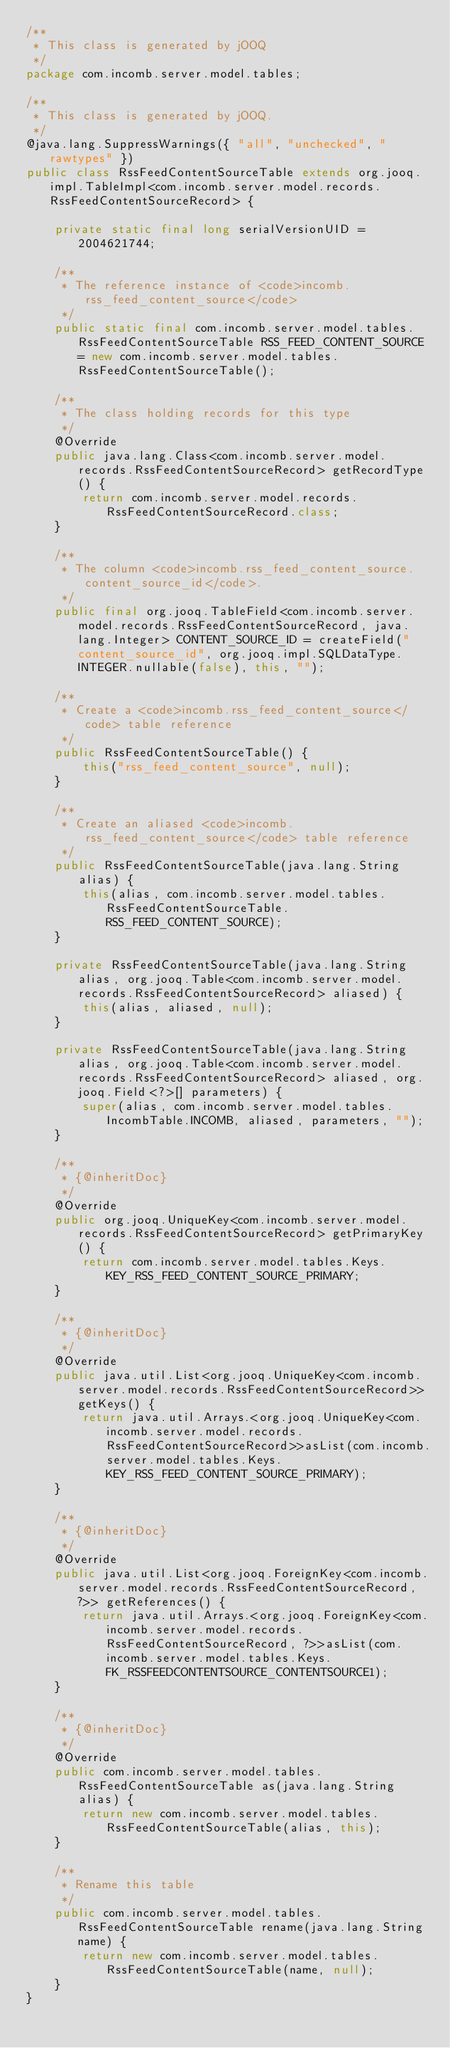<code> <loc_0><loc_0><loc_500><loc_500><_Java_>/**
 * This class is generated by jOOQ
 */
package com.incomb.server.model.tables;

/**
 * This class is generated by jOOQ.
 */
@java.lang.SuppressWarnings({ "all", "unchecked", "rawtypes" })
public class RssFeedContentSourceTable extends org.jooq.impl.TableImpl<com.incomb.server.model.records.RssFeedContentSourceRecord> {

	private static final long serialVersionUID = 2004621744;

	/**
	 * The reference instance of <code>incomb.rss_feed_content_source</code>
	 */
	public static final com.incomb.server.model.tables.RssFeedContentSourceTable RSS_FEED_CONTENT_SOURCE = new com.incomb.server.model.tables.RssFeedContentSourceTable();

	/**
	 * The class holding records for this type
	 */
	@Override
	public java.lang.Class<com.incomb.server.model.records.RssFeedContentSourceRecord> getRecordType() {
		return com.incomb.server.model.records.RssFeedContentSourceRecord.class;
	}

	/**
	 * The column <code>incomb.rss_feed_content_source.content_source_id</code>.
	 */
	public final org.jooq.TableField<com.incomb.server.model.records.RssFeedContentSourceRecord, java.lang.Integer> CONTENT_SOURCE_ID = createField("content_source_id", org.jooq.impl.SQLDataType.INTEGER.nullable(false), this, "");

	/**
	 * Create a <code>incomb.rss_feed_content_source</code> table reference
	 */
	public RssFeedContentSourceTable() {
		this("rss_feed_content_source", null);
	}

	/**
	 * Create an aliased <code>incomb.rss_feed_content_source</code> table reference
	 */
	public RssFeedContentSourceTable(java.lang.String alias) {
		this(alias, com.incomb.server.model.tables.RssFeedContentSourceTable.RSS_FEED_CONTENT_SOURCE);
	}

	private RssFeedContentSourceTable(java.lang.String alias, org.jooq.Table<com.incomb.server.model.records.RssFeedContentSourceRecord> aliased) {
		this(alias, aliased, null);
	}

	private RssFeedContentSourceTable(java.lang.String alias, org.jooq.Table<com.incomb.server.model.records.RssFeedContentSourceRecord> aliased, org.jooq.Field<?>[] parameters) {
		super(alias, com.incomb.server.model.tables.IncombTable.INCOMB, aliased, parameters, "");
	}

	/**
	 * {@inheritDoc}
	 */
	@Override
	public org.jooq.UniqueKey<com.incomb.server.model.records.RssFeedContentSourceRecord> getPrimaryKey() {
		return com.incomb.server.model.tables.Keys.KEY_RSS_FEED_CONTENT_SOURCE_PRIMARY;
	}

	/**
	 * {@inheritDoc}
	 */
	@Override
	public java.util.List<org.jooq.UniqueKey<com.incomb.server.model.records.RssFeedContentSourceRecord>> getKeys() {
		return java.util.Arrays.<org.jooq.UniqueKey<com.incomb.server.model.records.RssFeedContentSourceRecord>>asList(com.incomb.server.model.tables.Keys.KEY_RSS_FEED_CONTENT_SOURCE_PRIMARY);
	}

	/**
	 * {@inheritDoc}
	 */
	@Override
	public java.util.List<org.jooq.ForeignKey<com.incomb.server.model.records.RssFeedContentSourceRecord, ?>> getReferences() {
		return java.util.Arrays.<org.jooq.ForeignKey<com.incomb.server.model.records.RssFeedContentSourceRecord, ?>>asList(com.incomb.server.model.tables.Keys.FK_RSSFEEDCONTENTSOURCE_CONTENTSOURCE1);
	}

	/**
	 * {@inheritDoc}
	 */
	@Override
	public com.incomb.server.model.tables.RssFeedContentSourceTable as(java.lang.String alias) {
		return new com.incomb.server.model.tables.RssFeedContentSourceTable(alias, this);
	}

	/**
	 * Rename this table
	 */
	public com.incomb.server.model.tables.RssFeedContentSourceTable rename(java.lang.String name) {
		return new com.incomb.server.model.tables.RssFeedContentSourceTable(name, null);
	}
}
</code> 